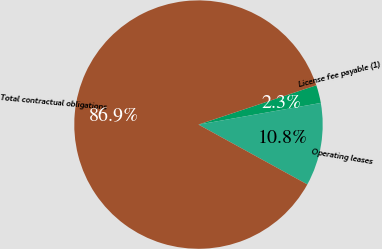Convert chart to OTSL. <chart><loc_0><loc_0><loc_500><loc_500><pie_chart><fcel>License fee payable (1)<fcel>Operating leases<fcel>Total contractual obligations<nl><fcel>2.34%<fcel>10.79%<fcel>86.88%<nl></chart> 